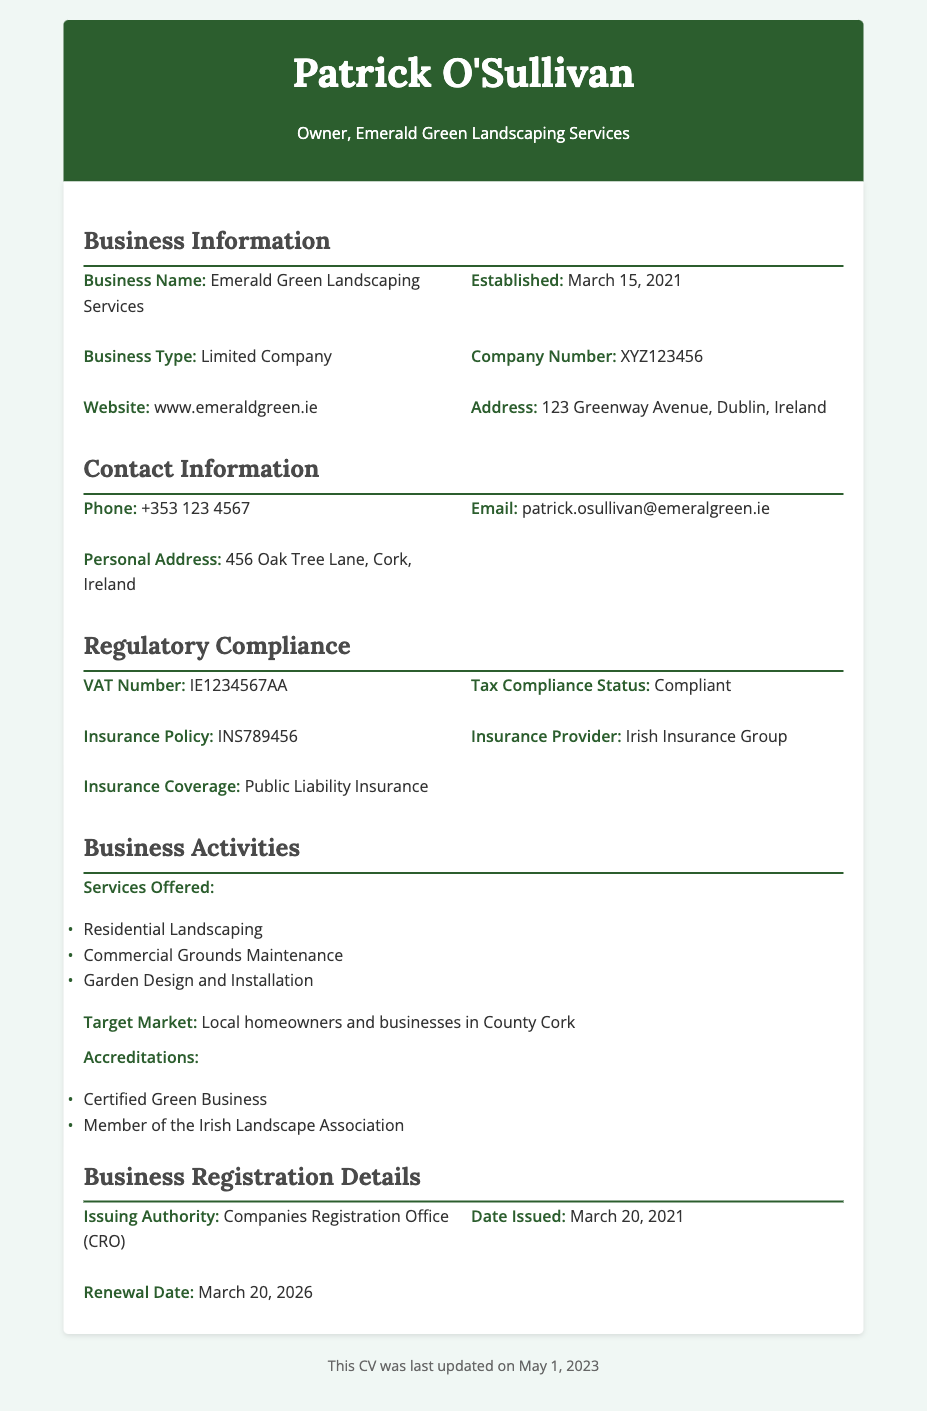What is the business name? The business name is provided in the "Business Information" section of the document.
Answer: Emerald Green Landscaping Services When was the business established? The establishment date is noted in the "Business Information" section.
Answer: March 15, 2021 What is the registered address? The registered address is listed under "Business Information."
Answer: 123 Greenway Avenue, Dublin, Ireland What is the company number? The company number can be found in the "Business Information" section.
Answer: XYZ123456 Who issued the Business Registration Certificate? The issuing authority is mentioned under the "Business Registration Details" section.
Answer: Companies Registration Office (CRO) What is the renewal date of the business registration? The renewal date is specified in the "Business Registration Details" section.
Answer: March 20, 2026 What services does the business offer? The offered services are listed under "Business Activities."
Answer: Residential Landscaping, Commercial Grounds Maintenance, Garden Design and Installation What is the VAT number? The VAT number is indicated in the "Regulatory Compliance" section.
Answer: IE1234567AA How often is the business registration renewed? The renewal period is calculated based on the issuance and renewal dates provided in the document.
Answer: Every 5 years 